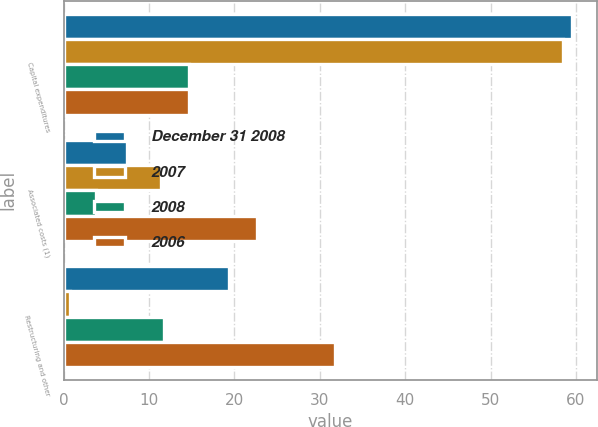Convert chart. <chart><loc_0><loc_0><loc_500><loc_500><stacked_bar_chart><ecel><fcel>Capital expenditures<fcel>Associated costs (1)<fcel>Restructuring and other<nl><fcel>December 31 2008<fcel>59.5<fcel>7.4<fcel>19.3<nl><fcel>2007<fcel>58.5<fcel>11.4<fcel>0.7<nl><fcel>2008<fcel>14.7<fcel>3.8<fcel>11.8<nl><fcel>2006<fcel>14.7<fcel>22.6<fcel>31.8<nl></chart> 